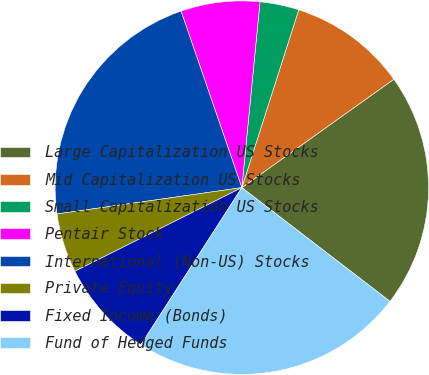Convert chart. <chart><loc_0><loc_0><loc_500><loc_500><pie_chart><fcel>Large Capitalization US Stocks<fcel>Mid Capitalization US Stocks<fcel>Small Capitalization US Stocks<fcel>Pentair Stock<fcel>International (Non-US) Stocks<fcel>Private Equity<fcel>Fixed Income (Bonds)<fcel>Fund of Hedged Funds<nl><fcel>20.28%<fcel>10.21%<fcel>3.38%<fcel>6.83%<fcel>21.97%<fcel>5.14%<fcel>8.52%<fcel>23.66%<nl></chart> 